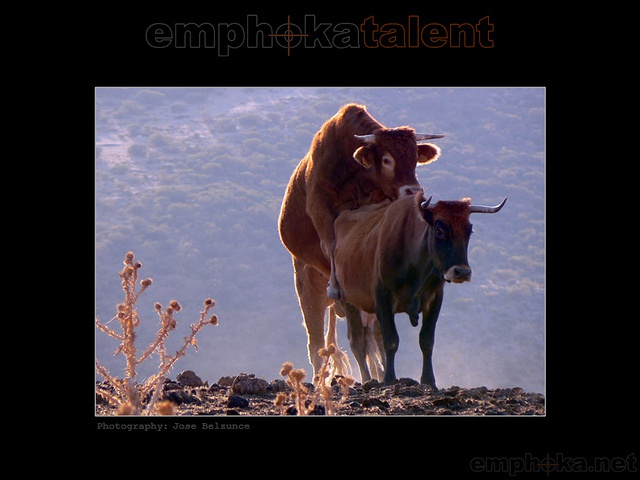Describe the objects in this image and their specific colors. I can see cow in black, maroon, and brown tones and cow in black, maroon, brown, and purple tones in this image. 